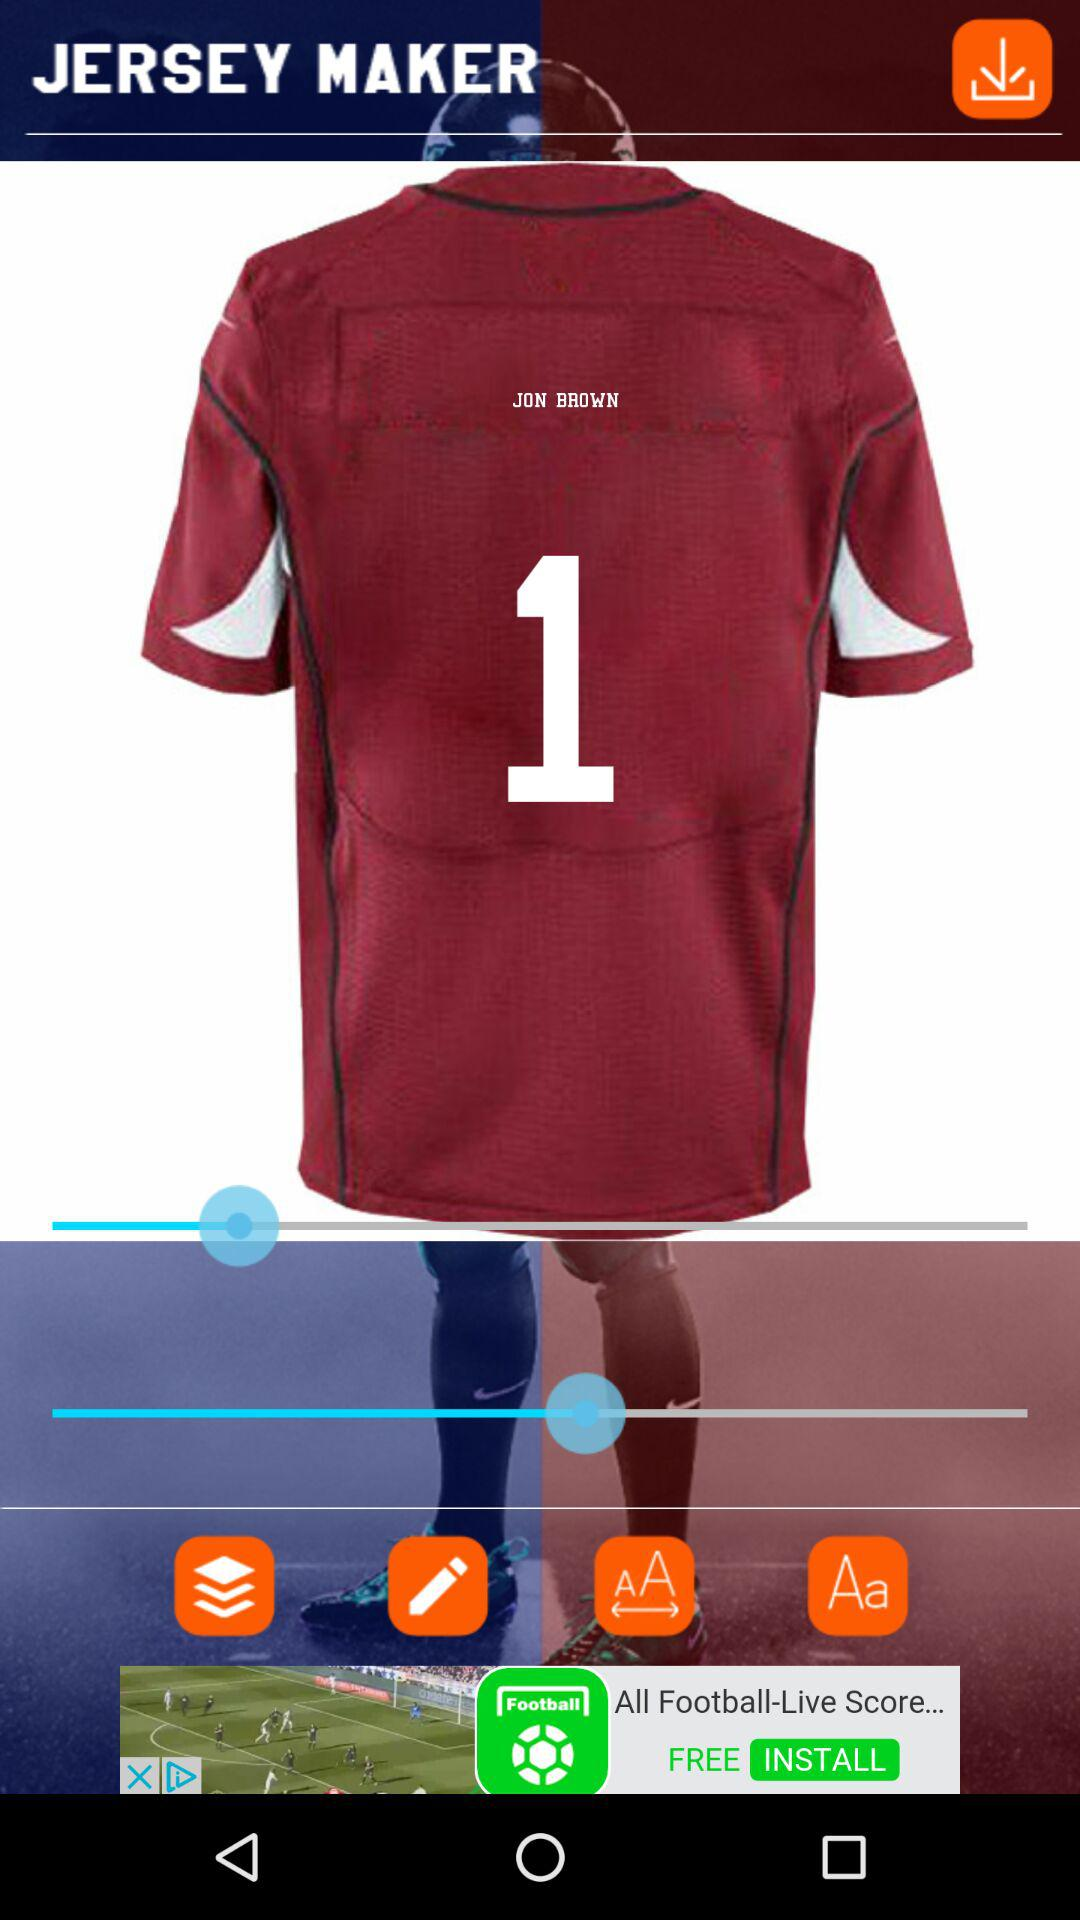What is the name written on the jersey? The name written on the jersey is Jon Brown. 